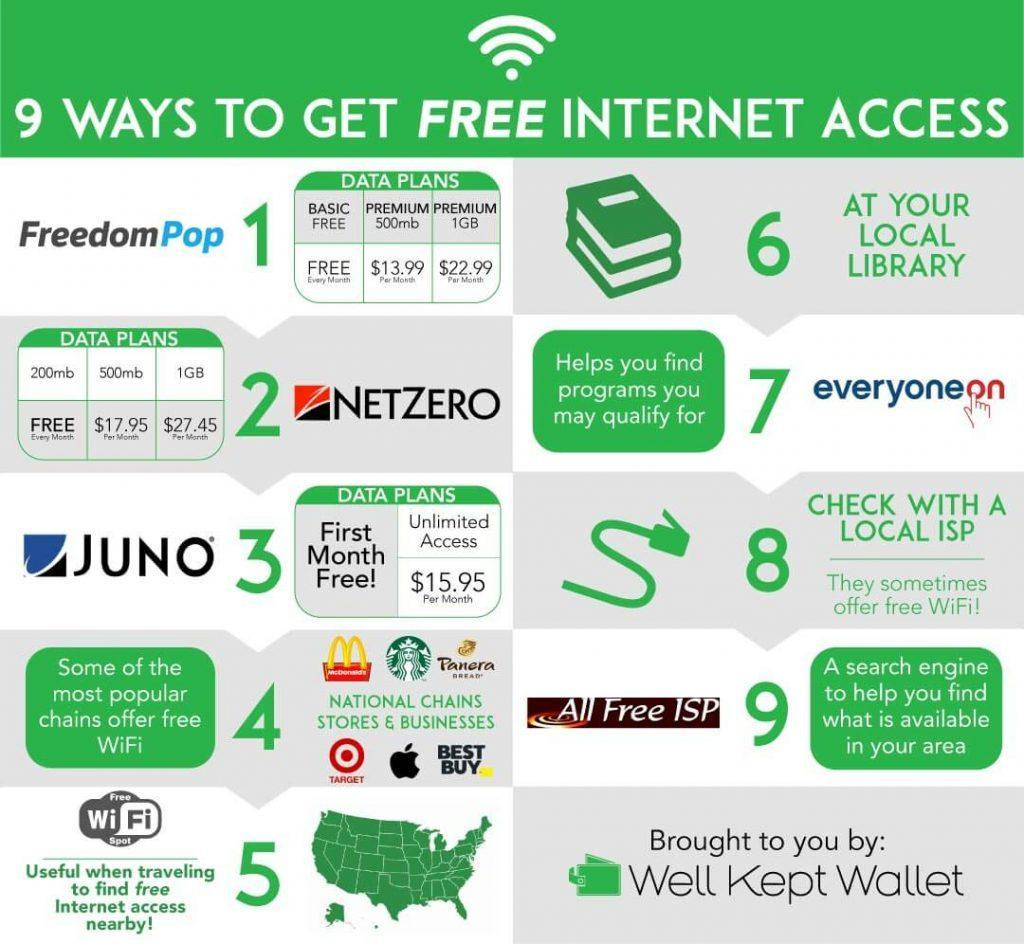How much is the unlimited data plan of JUNO costs per month?
Answer the question with a short phrase. $15.95 What is the cost of 500mb Netzero dataplan per month? $17.95 Per Month Which data plan of Netzero costs free every month? 200mb 